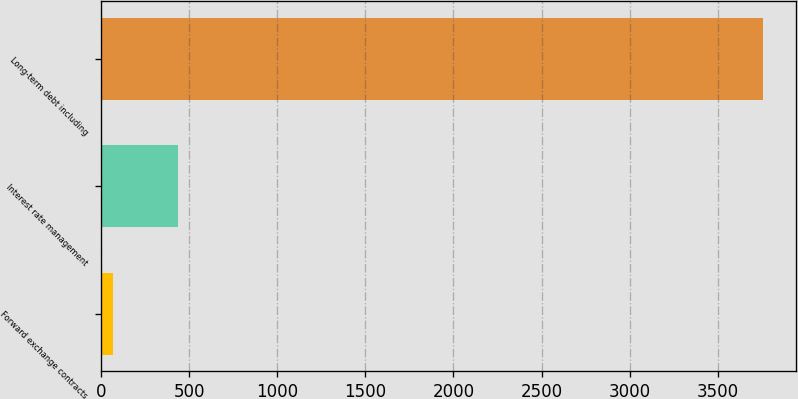Convert chart to OTSL. <chart><loc_0><loc_0><loc_500><loc_500><bar_chart><fcel>Forward exchange contracts<fcel>Interest rate management<fcel>Long-term debt including<nl><fcel>68.8<fcel>437.75<fcel>3758.3<nl></chart> 